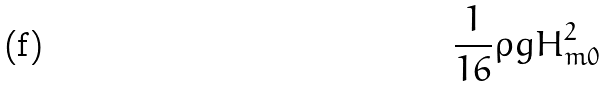<formula> <loc_0><loc_0><loc_500><loc_500>\frac { 1 } { 1 6 } \rho g H _ { m 0 } ^ { 2 }</formula> 